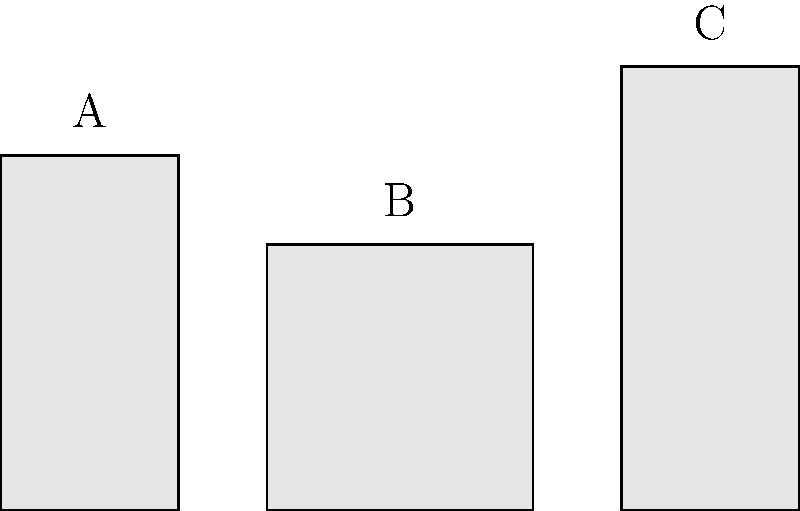As a writer who finds inspiration in aromatic teas, you're experimenting with different containers for storing your favorite tea leaves. You have three cylindrical containers (A, B, and C) with varying dimensions. If container B holds exactly 100 grams of tea leaves, estimate how many grams of tea leaves container C can hold, assuming the density of tea leaves remains constant. Let's approach this step-by-step:

1) First, we need to calculate the volumes of containers B and C.

2) For container B:
   Volume of B = $\pi r^2 h$
   $r = 1.5$ cm (half of the diameter)
   $h = 3$ cm
   $V_B = \pi (1.5\text{ cm})^2 (3\text{ cm}) = 21.21$ cm³

3) For container C:
   Volume of C = $\pi r^2 h$
   $r = 1$ cm (half of the diameter)
   $h = 5$ cm
   $V_C = \pi (1\text{ cm})^2 (5\text{ cm}) = 15.71$ cm³

4) Now, let's set up a proportion:
   $\frac{V_B}{100\text{ g}} = \frac{V_C}{x\text{ g}}$

5) Substituting the values:
   $\frac{21.21\text{ cm}³}{100\text{ g}} = \frac{15.71\text{ cm}³}{x\text{ g}}$

6) Cross multiply:
   $21.21x = 1571$

7) Solve for x:
   $x = \frac{1571}{21.21} = 74.07$ g

8) Rounding to the nearest gram:
   $x \approx 74$ g

Therefore, container C can hold approximately 74 grams of tea leaves.
Answer: 74 g 